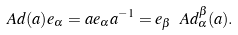<formula> <loc_0><loc_0><loc_500><loc_500>\ A d ( a ) e _ { \alpha } = a e _ { \alpha } a ^ { - 1 } = e _ { \beta } \ A d ^ { \beta } _ { \alpha } ( a ) .</formula> 